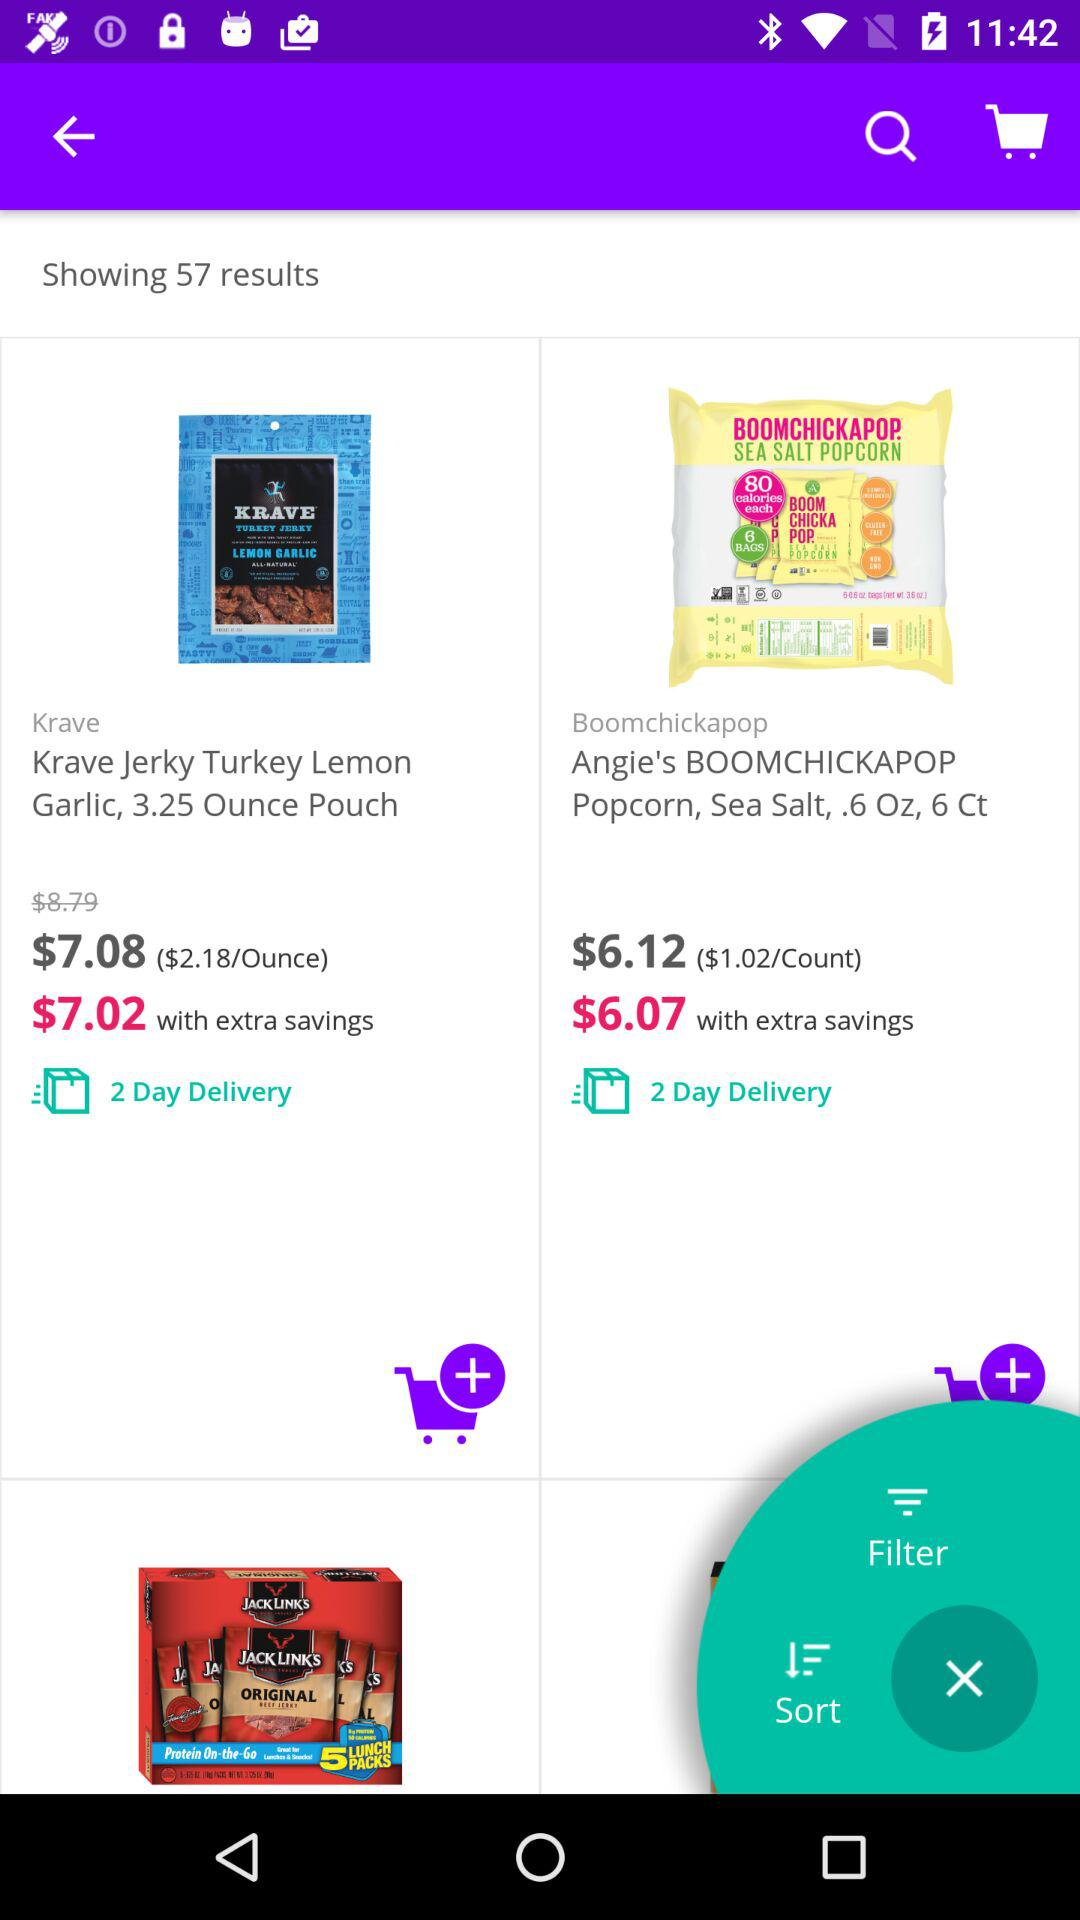How much does "Angie's BOOMCHICKAPOP Popcorn" cost? "Angie's BOOMCHICKAPOP Popcorn" costs $6.12 and $6.07. 